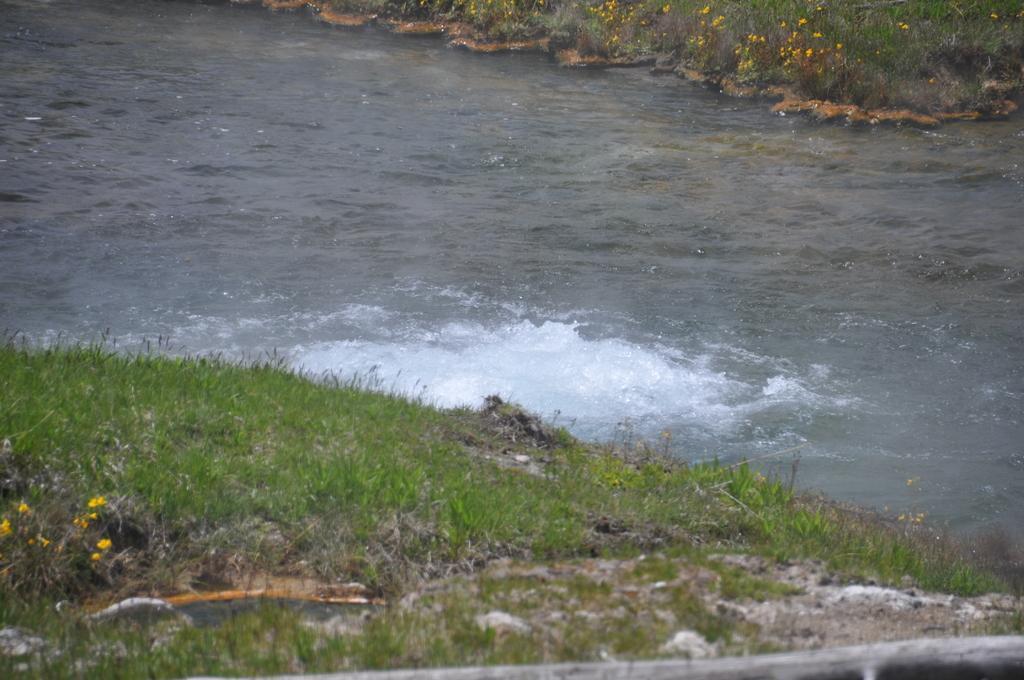How would you summarize this image in a sentence or two? In this image, I can see the grass. At the top of the image, these look like the plants with the tiny yellow flowers. I can see the water flowing. 